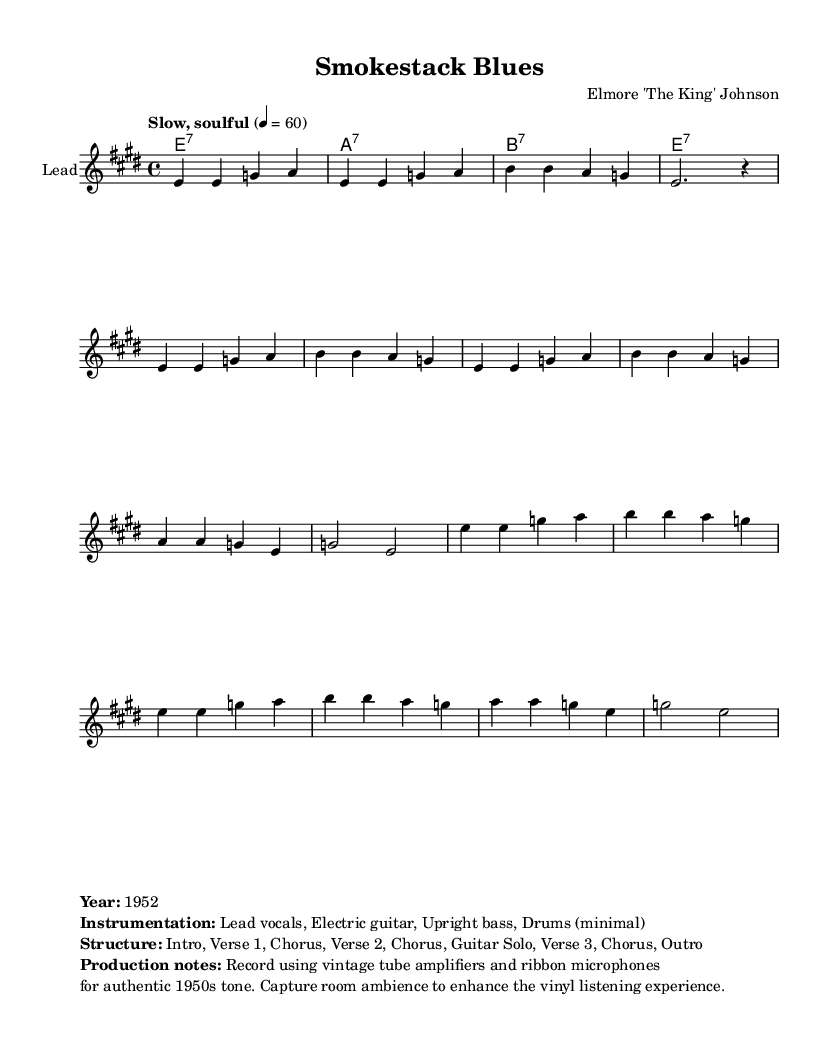What is the key signature of this music? The key signature is E major, which has four sharps (F#, C#, G#, D#). This can be identified from the key indication at the beginning of the score marked with \key e \major.
Answer: E major What is the time signature of this music? The time signature is 4/4, which indicates that there are four beats in each measure and a quarter note receives one beat. This is denoted at the start of the piece with \time 4/4.
Answer: 4/4 What is the tempo marking given for this piece? The tempo marking is "Slow, soulful," which conveys the intended feel of the music. This is visible in the score with the tempo instruction preceding the melody.
Answer: Slow, soulful How many verses are there in the structure? The structure includes three verses that are labeled as Verse 1, Verse 2, and Verse 3. This information is outlined in the production notes section within the markup after the score.
Answer: Three What instruments are primarily used in this recording? The primary instruments listed are Lead vocals, Electric guitar, Upright bass, and Drums (minimal). This is detailed in the instrumentation section of the markup text provided.
Answer: Lead vocals, Electric guitar, Upright bass, Drums What amplifiers and microphones were used for recording? The production notes specify that vintage tube amplifiers and ribbon microphones were used, which are essential for achieving the characteristic sound. These are mentioned directly in the production notes of the markup.
Answer: Vintage tube amplifiers, ribbon microphones What year was "Smokestack Blues" recorded? The year of recording is indicated as 1952 in the markup information provided at the end of the score. This reflects the time period of vintage blues music specifically mentioned here.
Answer: 1952 